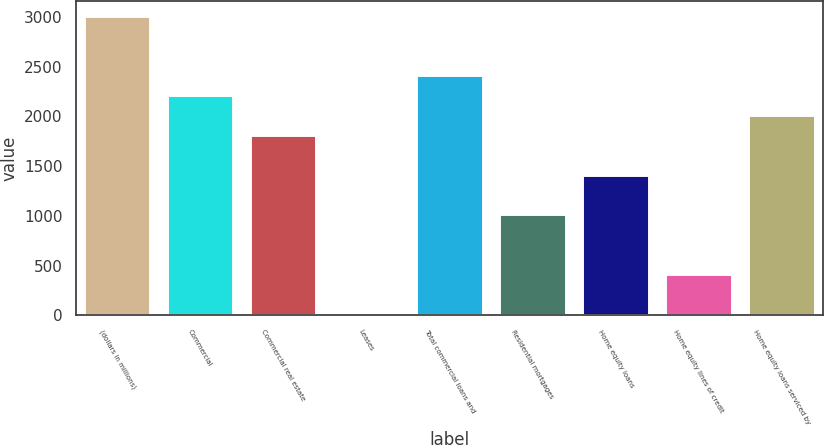Convert chart to OTSL. <chart><loc_0><loc_0><loc_500><loc_500><bar_chart><fcel>(dollars in millions)<fcel>Commercial<fcel>Commercial real estate<fcel>Leases<fcel>Total commercial loans and<fcel>Residential mortgages<fcel>Home equity loans<fcel>Home equity lines of credit<fcel>Home equity loans serviced by<nl><fcel>3010<fcel>2212.4<fcel>1813.6<fcel>19<fcel>2411.8<fcel>1016<fcel>1414.8<fcel>417.8<fcel>2013<nl></chart> 